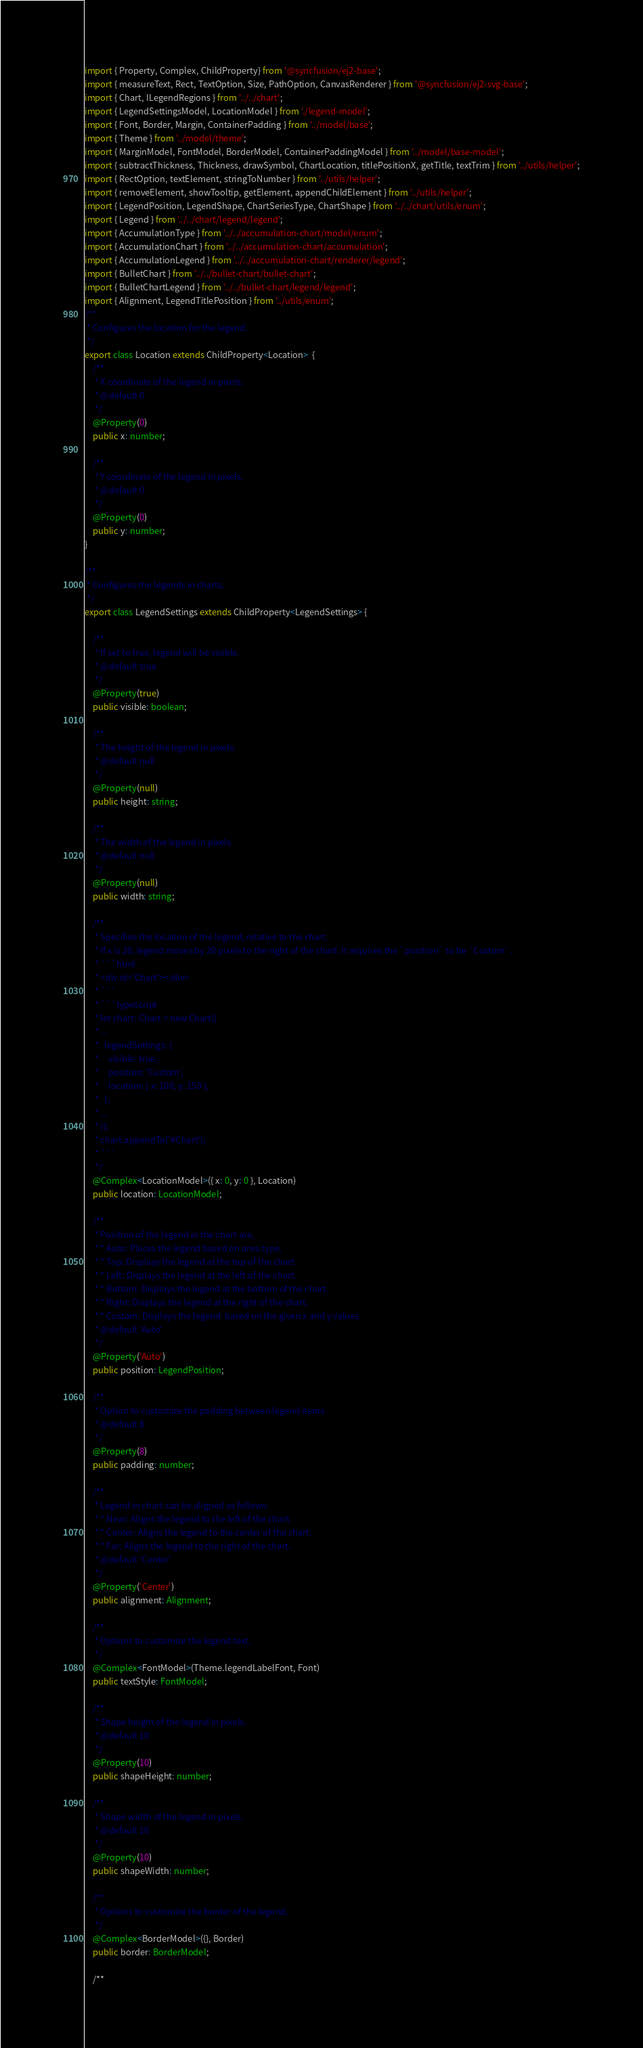<code> <loc_0><loc_0><loc_500><loc_500><_TypeScript_>import { Property, Complex, ChildProperty} from '@syncfusion/ej2-base';
import { measureText, Rect, TextOption, Size, PathOption, CanvasRenderer } from '@syncfusion/ej2-svg-base';
import { Chart, ILegendRegions } from '../../chart';
import { LegendSettingsModel, LocationModel } from './legend-model';
import { Font, Border, Margin, ContainerPadding } from '../model/base';
import { Theme } from '../model/theme';
import { MarginModel, FontModel, BorderModel, ContainerPaddingModel } from '../model/base-model';
import { subtractThickness, Thickness, drawSymbol, ChartLocation, titlePositionX, getTitle, textTrim } from '../utils/helper';
import { RectOption, textElement, stringToNumber } from '../utils/helper';
import { removeElement, showTooltip, getElement, appendChildElement } from '../utils/helper';
import { LegendPosition, LegendShape, ChartSeriesType, ChartShape } from '../../chart/utils/enum';
import { Legend } from '../../chart/legend/legend';
import { AccumulationType } from '../../accumulation-chart/model/enum';
import { AccumulationChart } from '../../accumulation-chart/accumulation';
import { AccumulationLegend } from '../../accumulation-chart/renderer/legend';
import { BulletChart } from '../../bullet-chart/bullet-chart';
import { BulletChartLegend } from '../../bullet-chart/legend/legend';
import { Alignment, LegendTitlePosition } from '../utils/enum';
/**
 * Configures the location for the legend.
 */
export class Location extends ChildProperty<Location>  {
    /**
     * X coordinate of the legend in pixels.
     * @default 0
     */
    @Property(0)
    public x: number;

    /**
     * Y coordinate of the legend in pixels.
     * @default 0
     */
    @Property(0)
    public y: number;
}

/**
 * Configures the legends in charts.
 */
export class LegendSettings extends ChildProperty<LegendSettings> {

    /**
     * If set to true, legend will be visible.
     * @default true
     */
    @Property(true)
    public visible: boolean;

    /**
     * The height of the legend in pixels.
     * @default null
     */
    @Property(null)
    public height: string;

    /**
     * The width of the legend in pixels.
     * @default null
     */
    @Property(null)
    public width: string;

    /**
     * Specifies the location of the legend, relative to the chart.
     * If x is 20, legend moves by 20 pixels to the right of the chart. It requires the `position` to be `Custom`.
     * ```html
     * <div id='Chart'></div>
     * ```
     * ```typescript
     * let chart: Chart = new Chart({
     * ...
     *   legendSettings: {
     *     visible: true,
     *     position: 'Custom',
     *     location: { x: 100, y: 150 },
     *   },
     * ...
     * });
     * chart.appendTo('#Chart');
     * ```
     */
    @Complex<LocationModel>({ x: 0, y: 0 }, Location)
    public location: LocationModel;

    /**
     * Position of the legend in the chart are,
     * * Auto: Places the legend based on area type.
     * * Top: Displays the legend at the top of the chart.
     * * Left: Displays the legend at the left of the chart.
     * * Bottom: Displays the legend at the bottom of the chart.
     * * Right: Displays the legend at the right of the chart.
     * * Custom: Displays the legend  based on the given x and y values.
     * @default 'Auto'
     */
    @Property('Auto')
    public position: LegendPosition;

    /**
     * Option to customize the padding between legend items.
     * @default 8
     */
    @Property(8)
    public padding: number;

    /**
     * Legend in chart can be aligned as follows:
     * * Near: Aligns the legend to the left of the chart.
     * * Center: Aligns the legend to the center of the chart.
     * * Far: Aligns the legend to the right of the chart.
     * @default 'Center'
     */
    @Property('Center')
    public alignment: Alignment;

    /**
     * Options to customize the legend text.
     */
    @Complex<FontModel>(Theme.legendLabelFont, Font)
    public textStyle: FontModel;

    /**
     * Shape height of the legend in pixels.
     * @default 10
     */
    @Property(10)
    public shapeHeight: number;

    /**
     * Shape width of the legend in pixels.
     * @default 10
     */
    @Property(10)
    public shapeWidth: number;

    /**
     * Options to customize the border of the legend.
     */
    @Complex<BorderModel>({}, Border)
    public border: BorderModel;

    /**</code> 